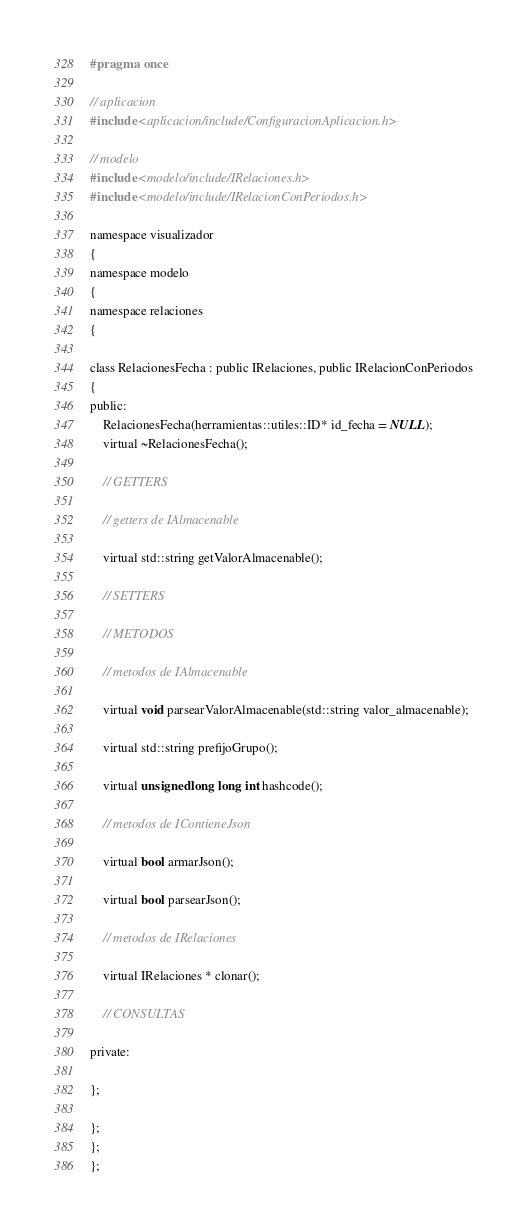Convert code to text. <code><loc_0><loc_0><loc_500><loc_500><_C_>#pragma once

// aplicacion
#include <aplicacion/include/ConfiguracionAplicacion.h>

// modelo
#include <modelo/include/IRelaciones.h>
#include <modelo/include/IRelacionConPeriodos.h>

namespace visualizador
{
namespace modelo
{
namespace relaciones
{

class RelacionesFecha : public IRelaciones, public IRelacionConPeriodos
{
public:
    RelacionesFecha(herramientas::utiles::ID* id_fecha = NULL);
    virtual ~RelacionesFecha();

    // GETTERS

    // getters de IAlmacenable

    virtual std::string getValorAlmacenable();

    // SETTERS

    // METODOS

    // metodos de IAlmacenable

    virtual void parsearValorAlmacenable(std::string valor_almacenable);

    virtual std::string prefijoGrupo();

    virtual unsigned long long int hashcode();

    // metodos de IContieneJson

    virtual bool armarJson();

    virtual bool parsearJson();

    // metodos de IRelaciones

    virtual IRelaciones * clonar();

    // CONSULTAS

private:

};

};
};
};
</code> 